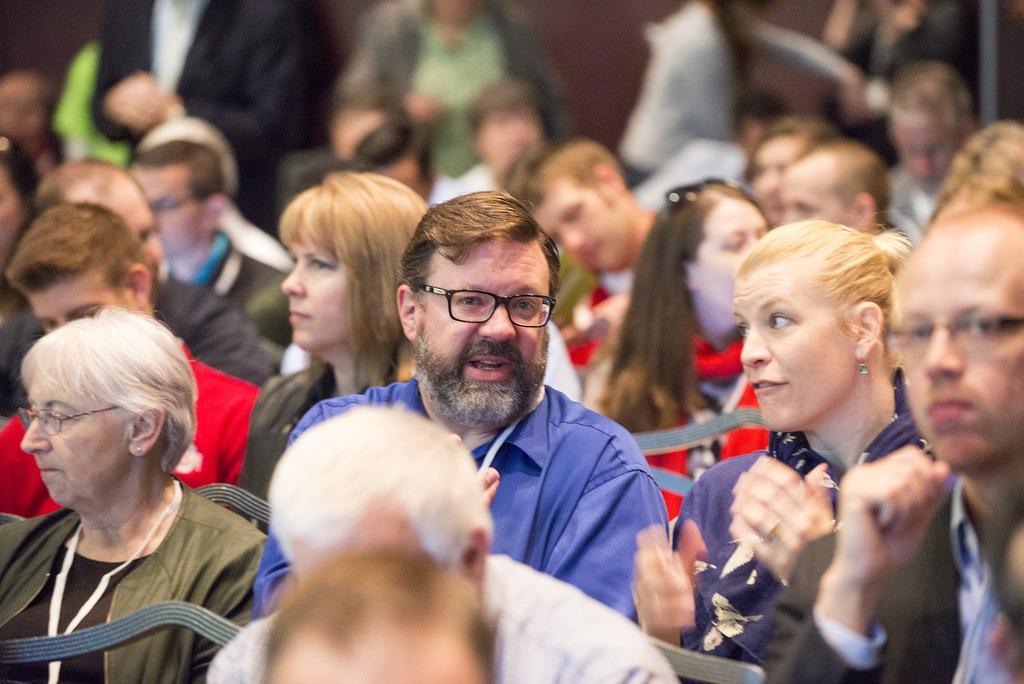Could you give a brief overview of what you see in this image? In front of the image there are people sitting on the chairs. Behind them there are a few people standing. In the background of the image there is a wall. 